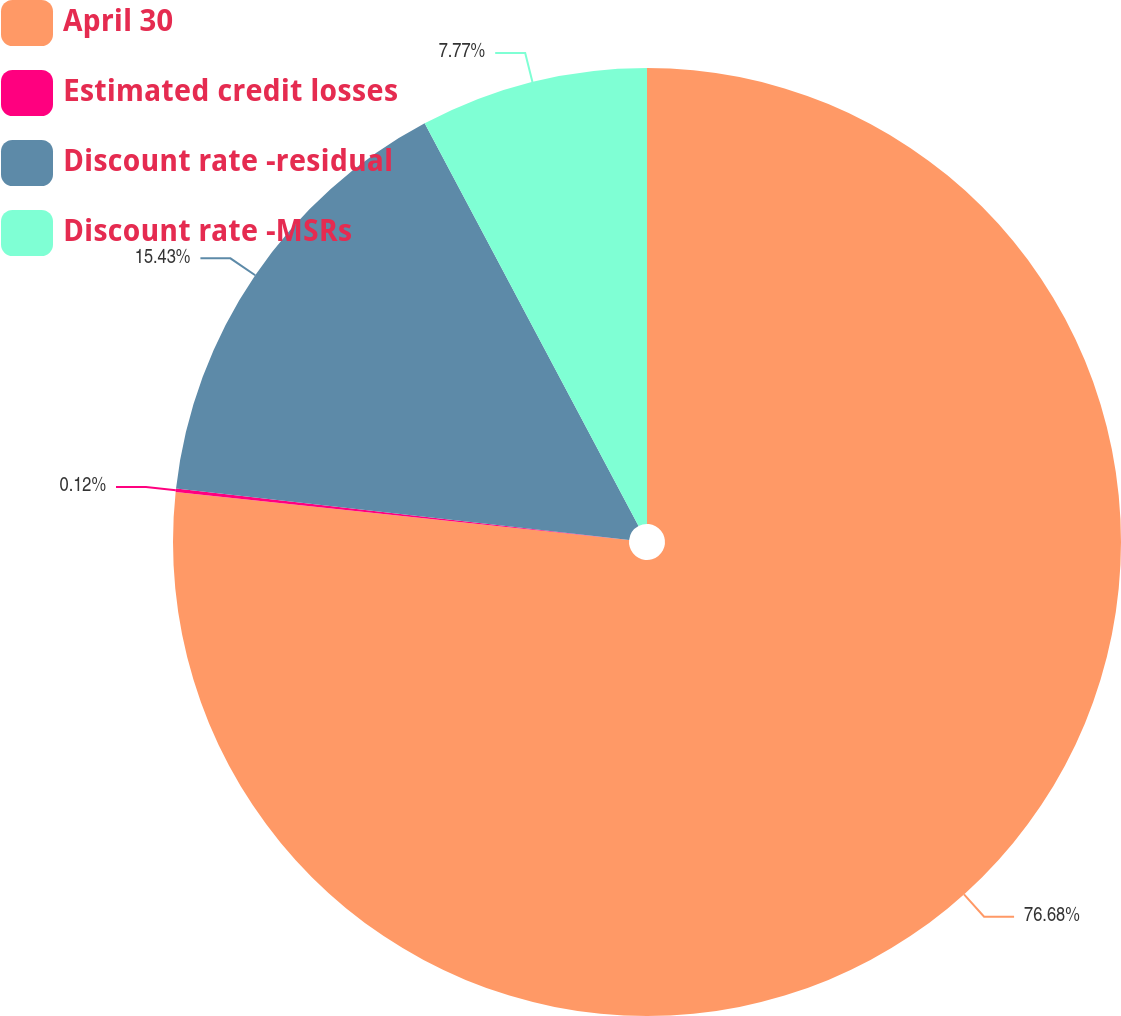Convert chart. <chart><loc_0><loc_0><loc_500><loc_500><pie_chart><fcel>April 30<fcel>Estimated credit losses<fcel>Discount rate -residual<fcel>Discount rate -MSRs<nl><fcel>76.68%<fcel>0.12%<fcel>15.43%<fcel>7.77%<nl></chart> 